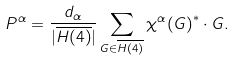Convert formula to latex. <formula><loc_0><loc_0><loc_500><loc_500>P ^ { \alpha } = \frac { d _ { \alpha } } { | \overline { H ( 4 ) } | } \sum _ { G \in \overline { H ( 4 ) } } { \chi ^ { \alpha } ( G ) } ^ { * } \cdot G .</formula> 